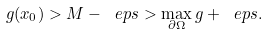<formula> <loc_0><loc_0><loc_500><loc_500>g ( x _ { 0 } ) > M - \ e p s > \max _ { \partial \Omega } g + \ e p s .</formula> 